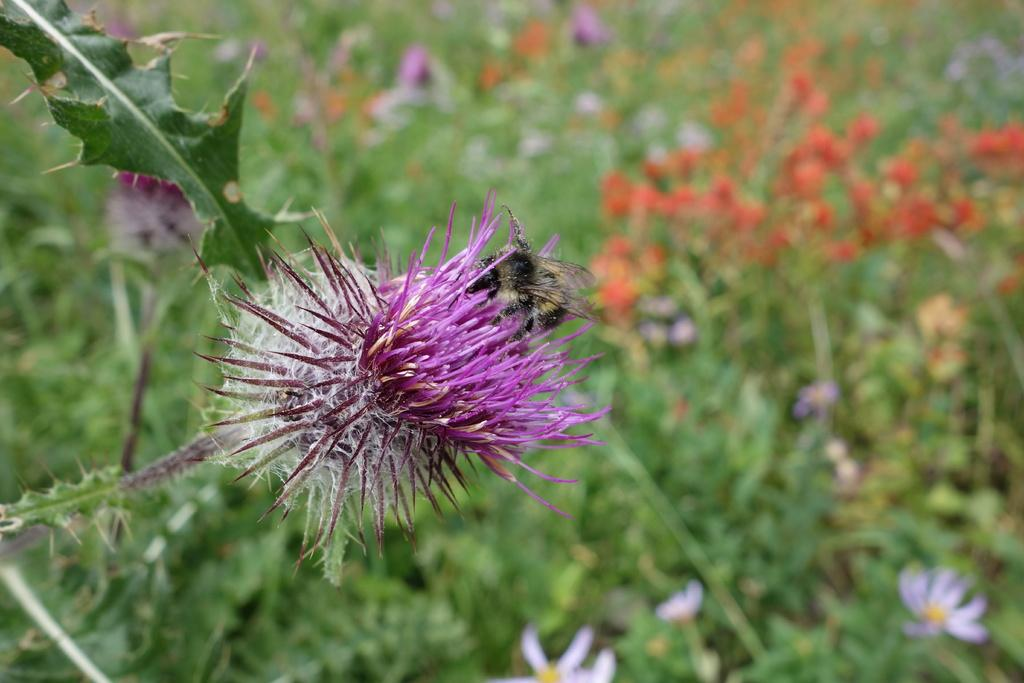What type of plant is featured in the image? There is a plant with a pine leaf and flower in the image. Are there any other plants visible in the image? Yes, there are other plants with flowers visible in the background, but they are not clearly visible. What is your aunt cooking in the image? There is no reference to an aunt or cooking in the image; it features a plant with a pine leaf and flower, along with other plants in the background. 